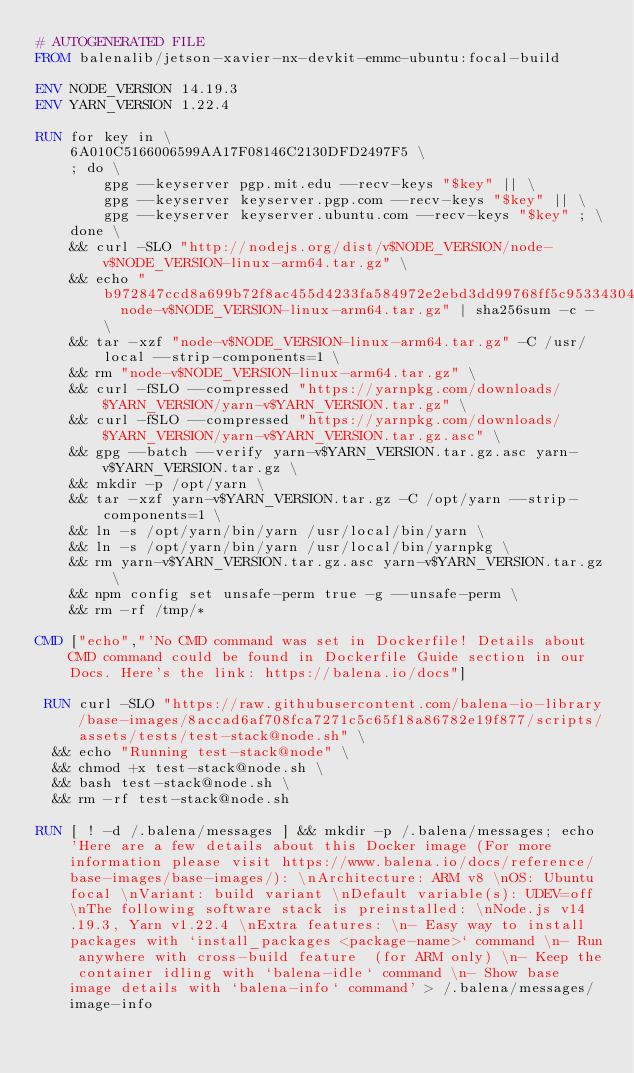Convert code to text. <code><loc_0><loc_0><loc_500><loc_500><_Dockerfile_># AUTOGENERATED FILE
FROM balenalib/jetson-xavier-nx-devkit-emmc-ubuntu:focal-build

ENV NODE_VERSION 14.19.3
ENV YARN_VERSION 1.22.4

RUN for key in \
	6A010C5166006599AA17F08146C2130DFD2497F5 \
	; do \
		gpg --keyserver pgp.mit.edu --recv-keys "$key" || \
		gpg --keyserver keyserver.pgp.com --recv-keys "$key" || \
		gpg --keyserver keyserver.ubuntu.com --recv-keys "$key" ; \
	done \
	&& curl -SLO "http://nodejs.org/dist/v$NODE_VERSION/node-v$NODE_VERSION-linux-arm64.tar.gz" \
	&& echo "b972847ccd8a699b72f8ac455d4233fa584972e2ebd3dd99768ff5c95334304d  node-v$NODE_VERSION-linux-arm64.tar.gz" | sha256sum -c - \
	&& tar -xzf "node-v$NODE_VERSION-linux-arm64.tar.gz" -C /usr/local --strip-components=1 \
	&& rm "node-v$NODE_VERSION-linux-arm64.tar.gz" \
	&& curl -fSLO --compressed "https://yarnpkg.com/downloads/$YARN_VERSION/yarn-v$YARN_VERSION.tar.gz" \
	&& curl -fSLO --compressed "https://yarnpkg.com/downloads/$YARN_VERSION/yarn-v$YARN_VERSION.tar.gz.asc" \
	&& gpg --batch --verify yarn-v$YARN_VERSION.tar.gz.asc yarn-v$YARN_VERSION.tar.gz \
	&& mkdir -p /opt/yarn \
	&& tar -xzf yarn-v$YARN_VERSION.tar.gz -C /opt/yarn --strip-components=1 \
	&& ln -s /opt/yarn/bin/yarn /usr/local/bin/yarn \
	&& ln -s /opt/yarn/bin/yarn /usr/local/bin/yarnpkg \
	&& rm yarn-v$YARN_VERSION.tar.gz.asc yarn-v$YARN_VERSION.tar.gz \
	&& npm config set unsafe-perm true -g --unsafe-perm \
	&& rm -rf /tmp/*

CMD ["echo","'No CMD command was set in Dockerfile! Details about CMD command could be found in Dockerfile Guide section in our Docs. Here's the link: https://balena.io/docs"]

 RUN curl -SLO "https://raw.githubusercontent.com/balena-io-library/base-images/8accad6af708fca7271c5c65f18a86782e19f877/scripts/assets/tests/test-stack@node.sh" \
  && echo "Running test-stack@node" \
  && chmod +x test-stack@node.sh \
  && bash test-stack@node.sh \
  && rm -rf test-stack@node.sh 

RUN [ ! -d /.balena/messages ] && mkdir -p /.balena/messages; echo 'Here are a few details about this Docker image (For more information please visit https://www.balena.io/docs/reference/base-images/base-images/): \nArchitecture: ARM v8 \nOS: Ubuntu focal \nVariant: build variant \nDefault variable(s): UDEV=off \nThe following software stack is preinstalled: \nNode.js v14.19.3, Yarn v1.22.4 \nExtra features: \n- Easy way to install packages with `install_packages <package-name>` command \n- Run anywhere with cross-build feature  (for ARM only) \n- Keep the container idling with `balena-idle` command \n- Show base image details with `balena-info` command' > /.balena/messages/image-info</code> 